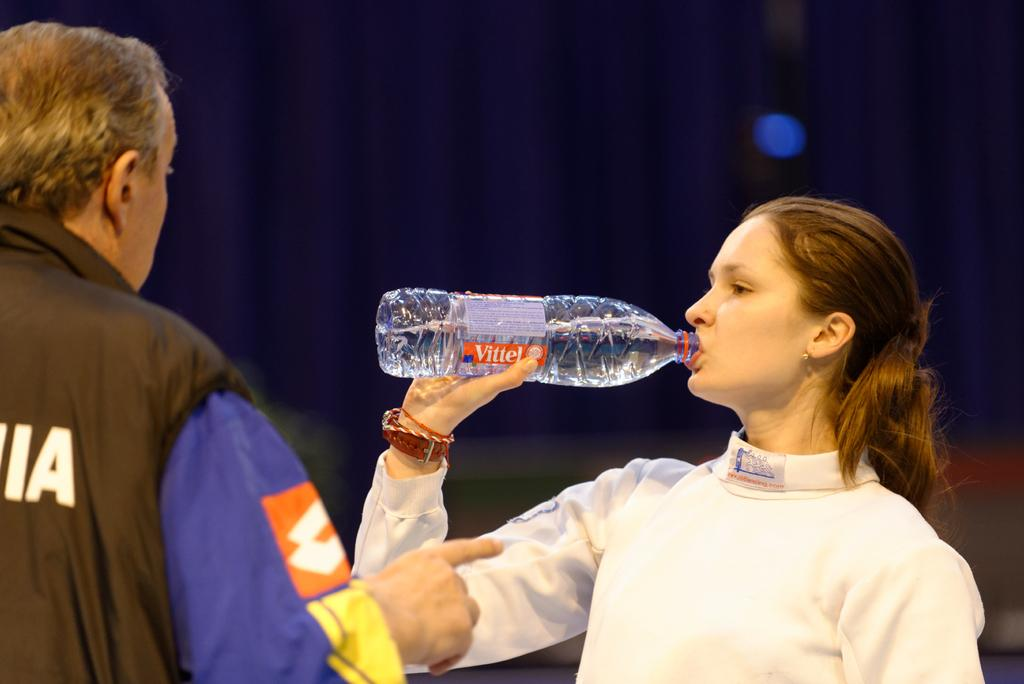<image>
Summarize the visual content of the image. a lady drinking a bottle next to a person with the letter A on their shirt 